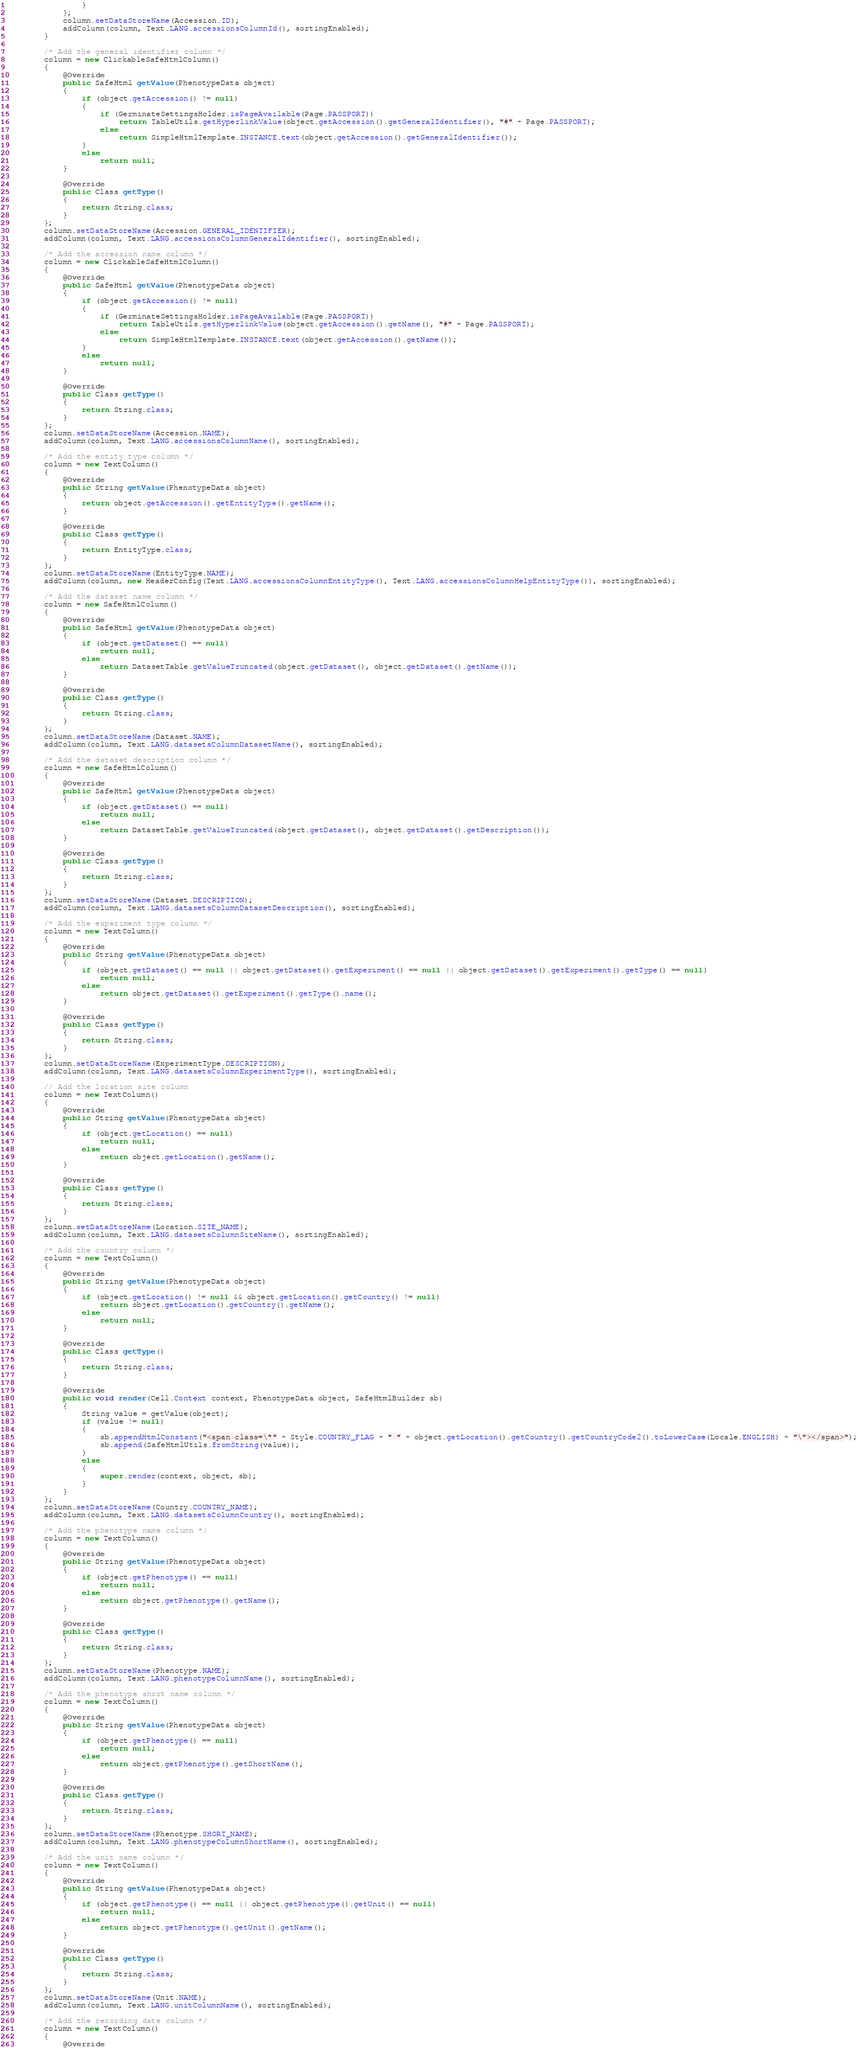Convert code to text. <code><loc_0><loc_0><loc_500><loc_500><_Java_>				}
			};
			column.setDataStoreName(Accession.ID);
			addColumn(column, Text.LANG.accessionsColumnId(), sortingEnabled);
		}

		/* Add the general identifier column */
		column = new ClickableSafeHtmlColumn()
		{
			@Override
			public SafeHtml getValue(PhenotypeData object)
			{
				if (object.getAccession() != null)
				{
					if (GerminateSettingsHolder.isPageAvailable(Page.PASSPORT))
						return TableUtils.getHyperlinkValue(object.getAccession().getGeneralIdentifier(), "#" + Page.PASSPORT);
					else
						return SimpleHtmlTemplate.INSTANCE.text(object.getAccession().getGeneralIdentifier());
				}
				else
					return null;
			}

			@Override
			public Class getType()
			{
				return String.class;
			}
		};
		column.setDataStoreName(Accession.GENERAL_IDENTIFIER);
		addColumn(column, Text.LANG.accessionsColumnGeneralIdentifier(), sortingEnabled);

		/* Add the accession name column */
		column = new ClickableSafeHtmlColumn()
		{
			@Override
			public SafeHtml getValue(PhenotypeData object)
			{
				if (object.getAccession() != null)
				{
					if (GerminateSettingsHolder.isPageAvailable(Page.PASSPORT))
						return TableUtils.getHyperlinkValue(object.getAccession().getName(), "#" + Page.PASSPORT);
					else
						return SimpleHtmlTemplate.INSTANCE.text(object.getAccession().getName());
				}
				else
					return null;
			}

			@Override
			public Class getType()
			{
				return String.class;
			}
		};
		column.setDataStoreName(Accession.NAME);
		addColumn(column, Text.LANG.accessionsColumnName(), sortingEnabled);

		/* Add the entity type column */
		column = new TextColumn()
		{
			@Override
			public String getValue(PhenotypeData object)
			{
				return object.getAccession().getEntityType().getName();
			}

			@Override
			public Class getType()
			{
				return EntityType.class;
			}
		};
		column.setDataStoreName(EntityType.NAME);
		addColumn(column, new HeaderConfig(Text.LANG.accessionsColumnEntityType(), Text.LANG.accessionsColumnHelpEntityType()), sortingEnabled);

		/* Add the dataset name column */
		column = new SafeHtmlColumn()
		{
			@Override
			public SafeHtml getValue(PhenotypeData object)
			{
				if (object.getDataset() == null)
					return null;
				else
					return DatasetTable.getValueTruncated(object.getDataset(), object.getDataset().getName());
			}

			@Override
			public Class getType()
			{
				return String.class;
			}
		};
		column.setDataStoreName(Dataset.NAME);
		addColumn(column, Text.LANG.datasetsColumnDatasetName(), sortingEnabled);

		/* Add the dataset description column */
		column = new SafeHtmlColumn()
		{
			@Override
			public SafeHtml getValue(PhenotypeData object)
			{
				if (object.getDataset() == null)
					return null;
				else
					return DatasetTable.getValueTruncated(object.getDataset(), object.getDataset().getDescription());
			}

			@Override
			public Class getType()
			{
				return String.class;
			}
		};
		column.setDataStoreName(Dataset.DESCRIPTION);
		addColumn(column, Text.LANG.datasetsColumnDatasetDescription(), sortingEnabled);

		/* Add the experiment type column */
		column = new TextColumn()
		{
			@Override
			public String getValue(PhenotypeData object)
			{
				if (object.getDataset() == null || object.getDataset().getExperiment() == null || object.getDataset().getExperiment().getType() == null)
					return null;
				else
					return object.getDataset().getExperiment().getType().name();
			}

			@Override
			public Class getType()
			{
				return String.class;
			}
		};
		column.setDataStoreName(ExperimentType.DESCRIPTION);
		addColumn(column, Text.LANG.datasetsColumnExperimentType(), sortingEnabled);

		// Add the location site column
		column = new TextColumn()
		{
			@Override
			public String getValue(PhenotypeData object)
			{
				if (object.getLocation() == null)
					return null;
				else
					return object.getLocation().getName();
			}

			@Override
			public Class getType()
			{
				return String.class;
			}
		};
		column.setDataStoreName(Location.SITE_NAME);
		addColumn(column, Text.LANG.datasetsColumnSiteName(), sortingEnabled);

		/* Add the country column */
		column = new TextColumn()
		{
			@Override
			public String getValue(PhenotypeData object)
			{
				if (object.getLocation() != null && object.getLocation().getCountry() != null)
					return object.getLocation().getCountry().getName();
				else
					return null;
			}

			@Override
			public Class getType()
			{
				return String.class;
			}

			@Override
			public void render(Cell.Context context, PhenotypeData object, SafeHtmlBuilder sb)
			{
				String value = getValue(object);
				if (value != null)
				{
					sb.appendHtmlConstant("<span class=\"" + Style.COUNTRY_FLAG + " " + object.getLocation().getCountry().getCountryCode2().toLowerCase(Locale.ENGLISH) + "\"></span>");
					sb.append(SafeHtmlUtils.fromString(value));
				}
				else
				{
					super.render(context, object, sb);
				}
			}
		};
		column.setDataStoreName(Country.COUNTRY_NAME);
		addColumn(column, Text.LANG.datasetsColumnCountry(), sortingEnabled);

		/* Add the phenotype name column */
		column = new TextColumn()
		{
			@Override
			public String getValue(PhenotypeData object)
			{
				if (object.getPhenotype() == null)
					return null;
				else
					return object.getPhenotype().getName();
			}

			@Override
			public Class getType()
			{
				return String.class;
			}
		};
		column.setDataStoreName(Phenotype.NAME);
		addColumn(column, Text.LANG.phenotypeColumnName(), sortingEnabled);

		/* Add the phenotype short name column */
		column = new TextColumn()
		{
			@Override
			public String getValue(PhenotypeData object)
			{
				if (object.getPhenotype() == null)
					return null;
				else
					return object.getPhenotype().getShortName();
			}

			@Override
			public Class getType()
			{
				return String.class;
			}
		};
		column.setDataStoreName(Phenotype.SHORT_NAME);
		addColumn(column, Text.LANG.phenotypeColumnShortName(), sortingEnabled);

		/* Add the unit name column */
		column = new TextColumn()
		{
			@Override
			public String getValue(PhenotypeData object)
			{
				if (object.getPhenotype() == null || object.getPhenotype().getUnit() == null)
					return null;
				else
					return object.getPhenotype().getUnit().getName();
			}

			@Override
			public Class getType()
			{
				return String.class;
			}
		};
		column.setDataStoreName(Unit.NAME);
		addColumn(column, Text.LANG.unitColumnName(), sortingEnabled);

		/* Add the recording date column */
		column = new TextColumn()
		{
			@Override</code> 